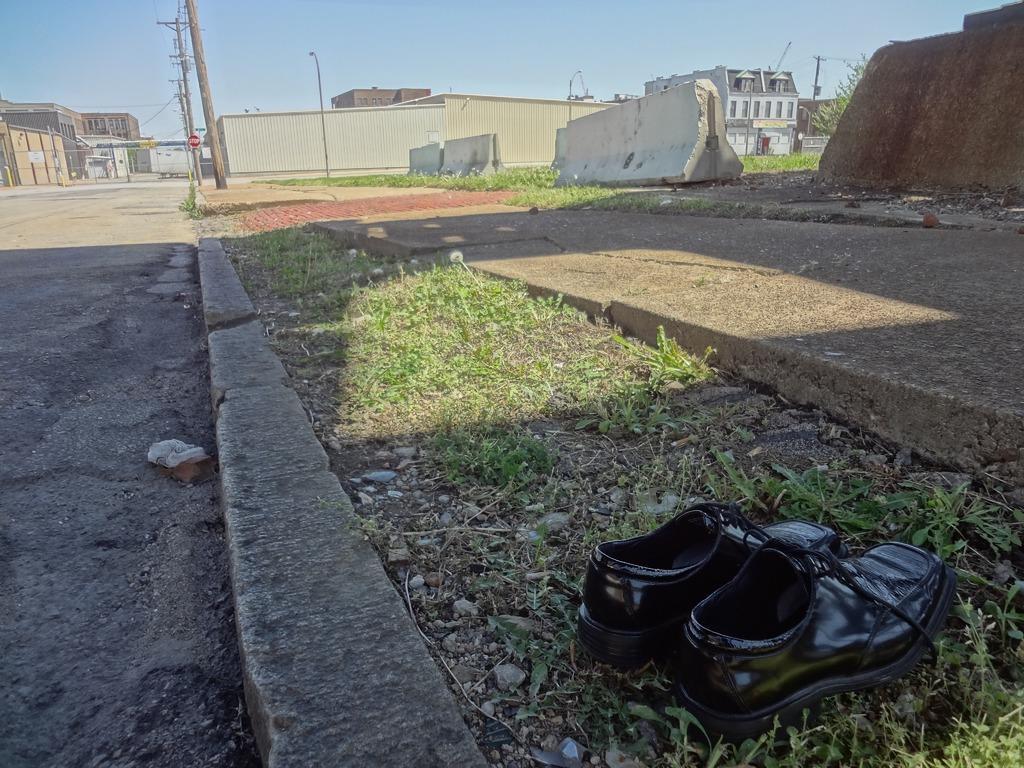In one or two sentences, can you explain what this image depicts? In this image there is a pair of shoes in the bottom of this image and there is some grass as we can see in the middle of this image. There are some buildings in the background. There is a sky on the top of this image. There are some current polls on the top left side of this image. 